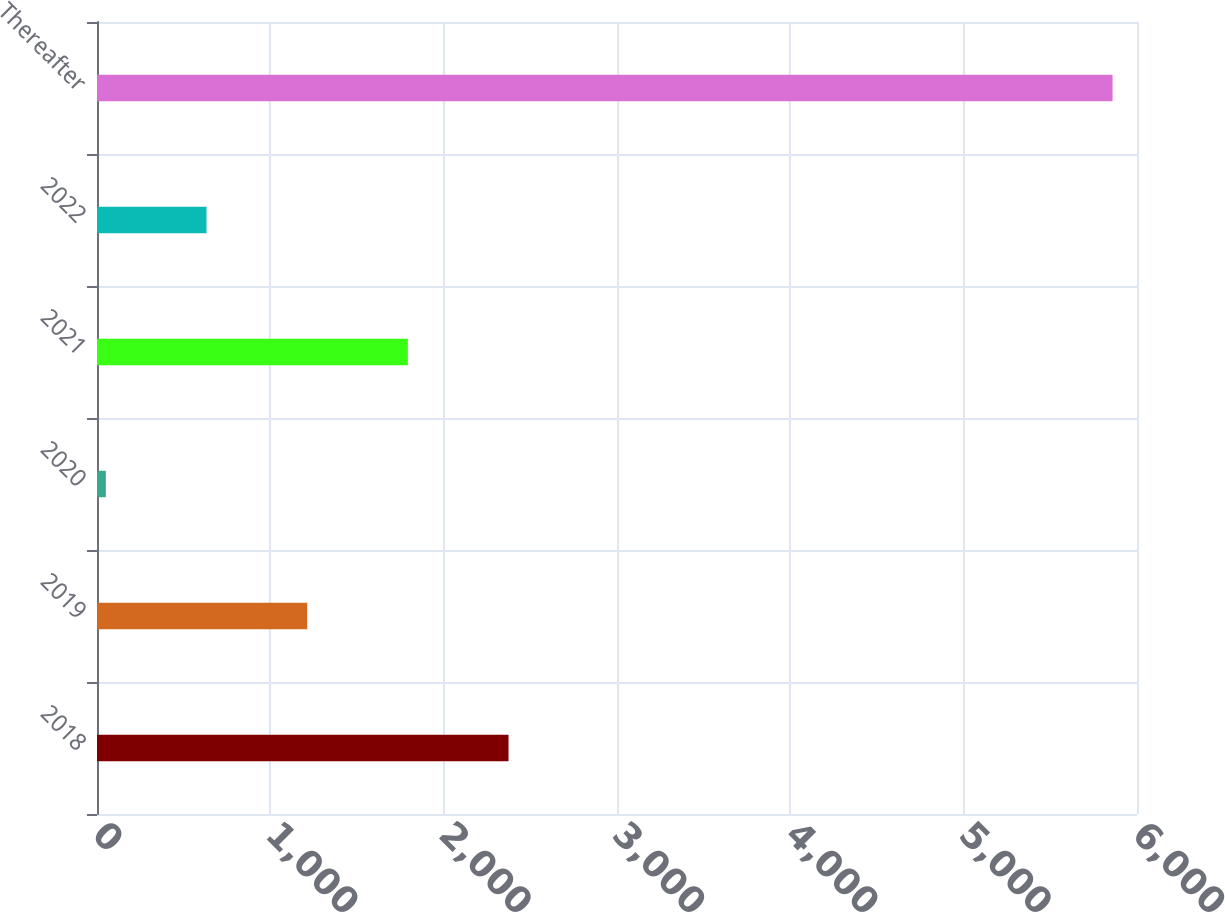Convert chart to OTSL. <chart><loc_0><loc_0><loc_500><loc_500><bar_chart><fcel>2018<fcel>2019<fcel>2020<fcel>2021<fcel>2022<fcel>Thereafter<nl><fcel>2374.2<fcel>1212.6<fcel>51<fcel>1793.4<fcel>631.8<fcel>5859<nl></chart> 